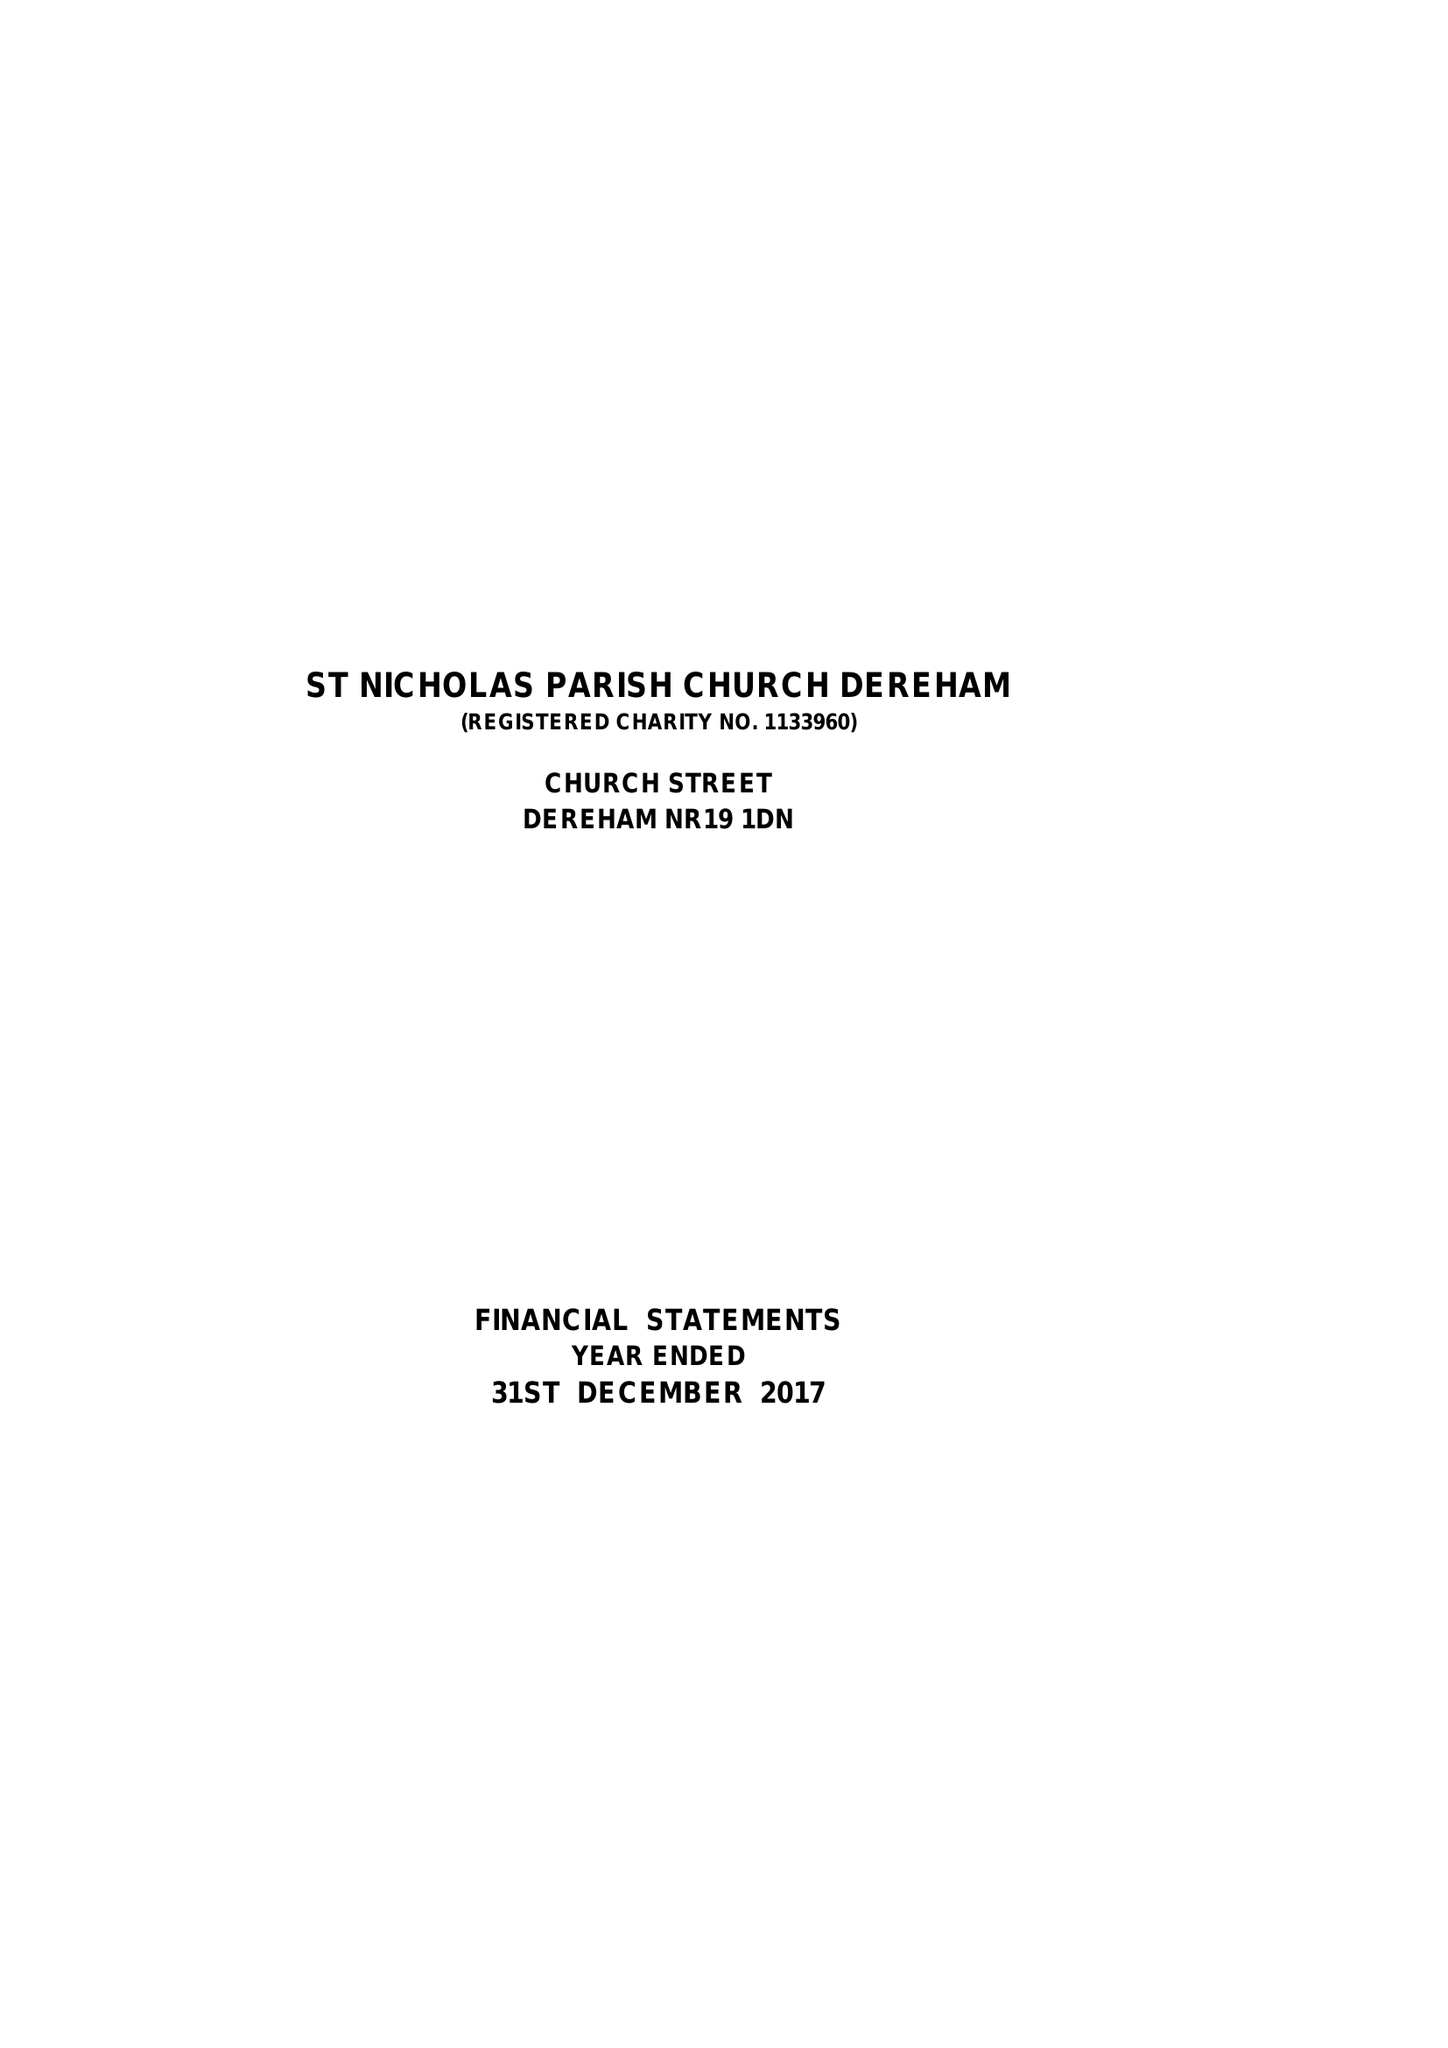What is the value for the address__post_town?
Answer the question using a single word or phrase. DEREHAM 